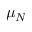Convert formula to latex. <formula><loc_0><loc_0><loc_500><loc_500>\mu _ { N }</formula> 